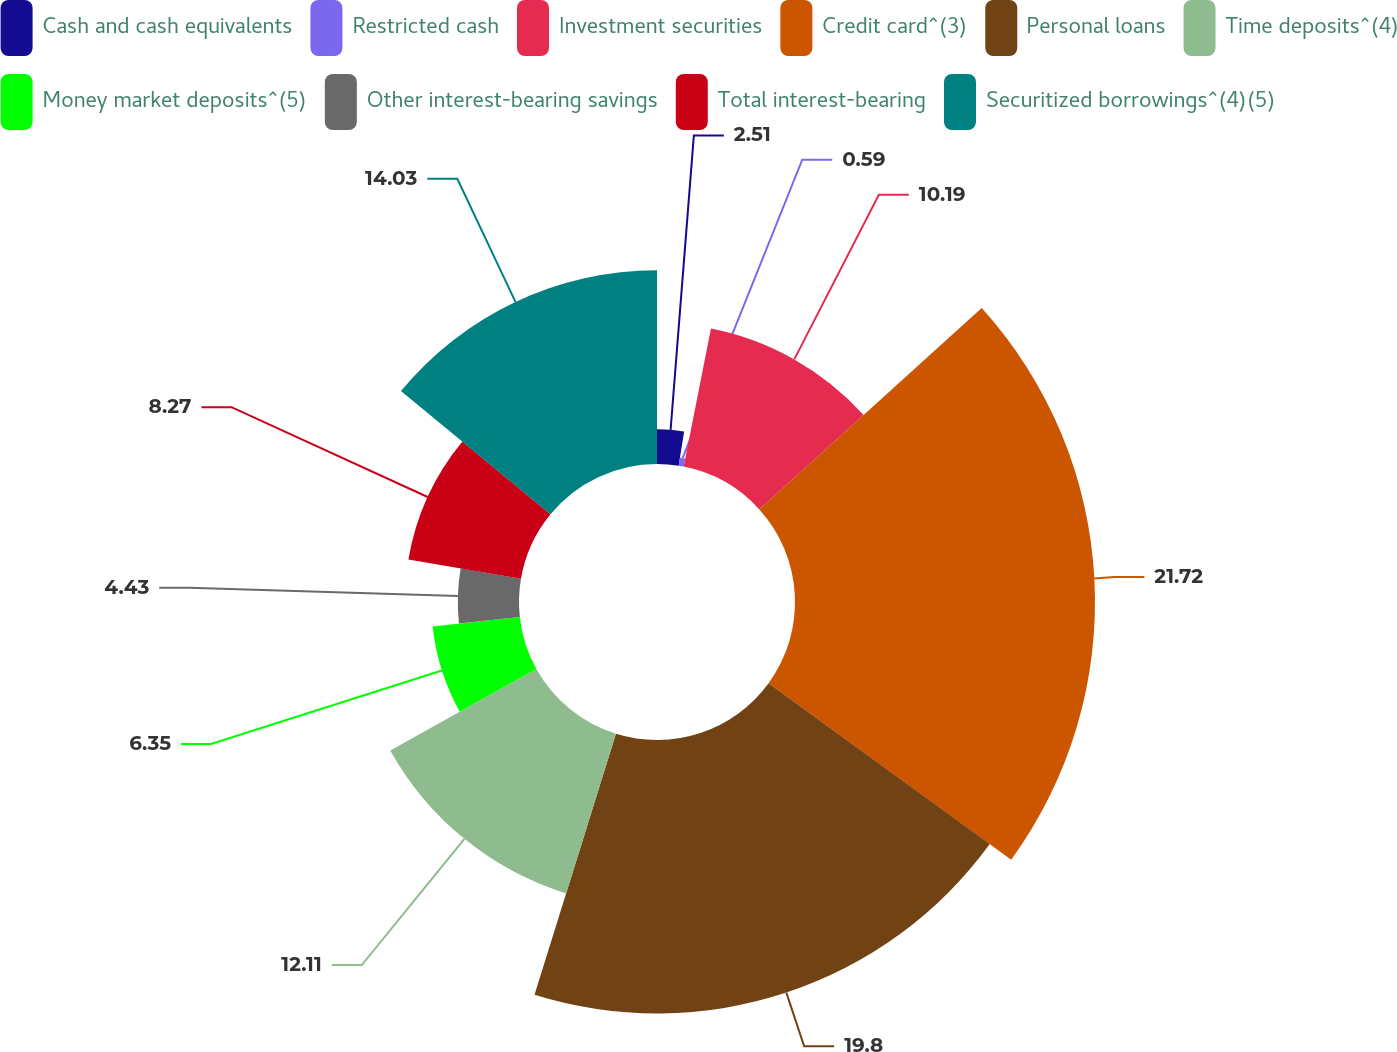Convert chart to OTSL. <chart><loc_0><loc_0><loc_500><loc_500><pie_chart><fcel>Cash and cash equivalents<fcel>Restricted cash<fcel>Investment securities<fcel>Credit card^(3)<fcel>Personal loans<fcel>Time deposits^(4)<fcel>Money market deposits^(5)<fcel>Other interest-bearing savings<fcel>Total interest-bearing<fcel>Securitized borrowings^(4)(5)<nl><fcel>2.51%<fcel>0.59%<fcel>10.19%<fcel>21.72%<fcel>19.8%<fcel>12.11%<fcel>6.35%<fcel>4.43%<fcel>8.27%<fcel>14.03%<nl></chart> 